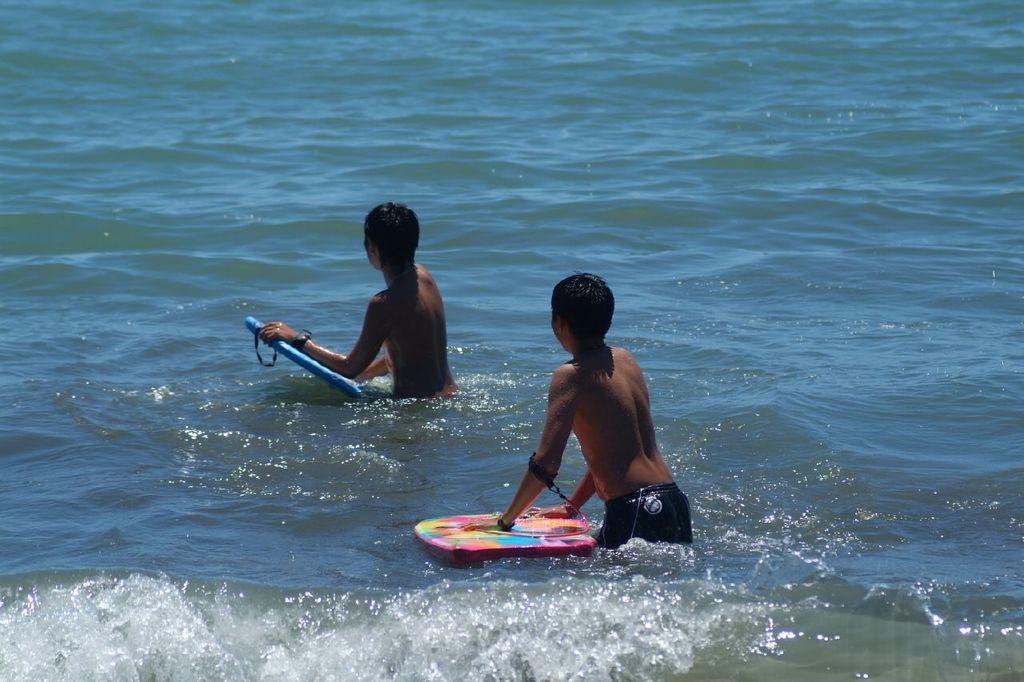What are the two people in the image doing? The two people in the image are swimming in the water. What else can be seen in the image besides the people swimming? There is a skateboard visible in the image. What type of wren can be seen perched on the skateboard in the image? There is no wren present in the image; only the two people swimming and the skateboard are visible. 